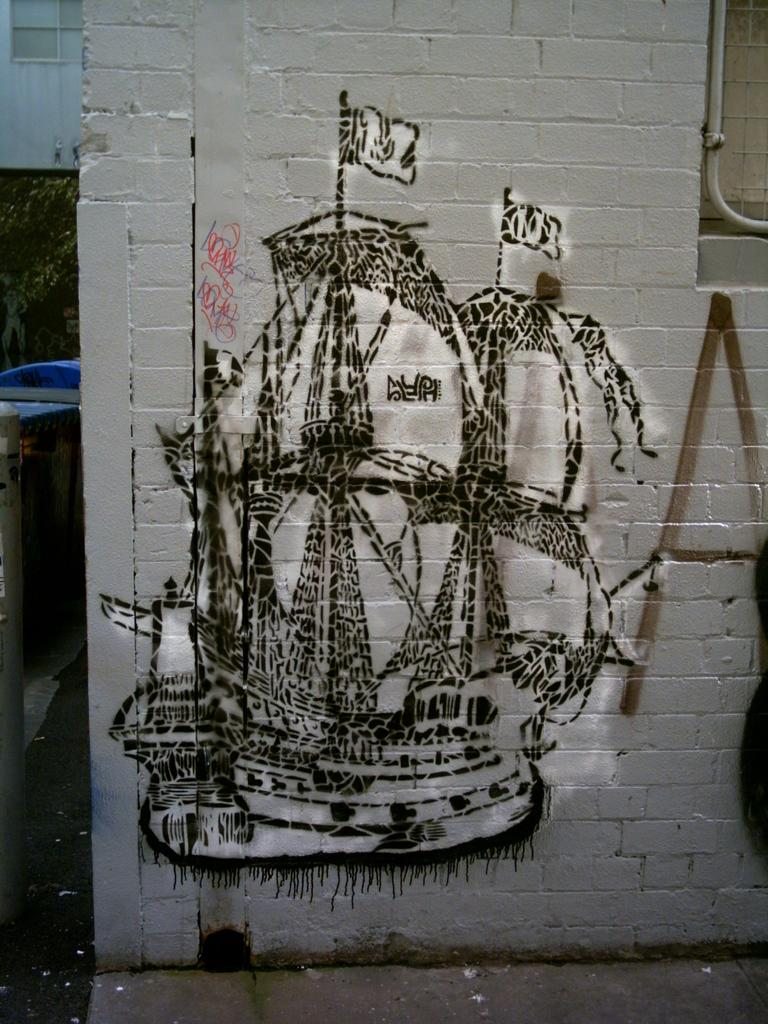What is the color of the wall in the image? The wall in the image is white-colored. What is depicted on the wall? There is a drawing of a ship on the wall. Can you describe the object on the left side of the image? There is a blue-colored object on the left side of the image. How many ladybugs can be seen crawling on the wall in the image? There are no ladybugs present in the image; it only features a drawing of a ship on a white wall and a blue-colored object on the left side. 